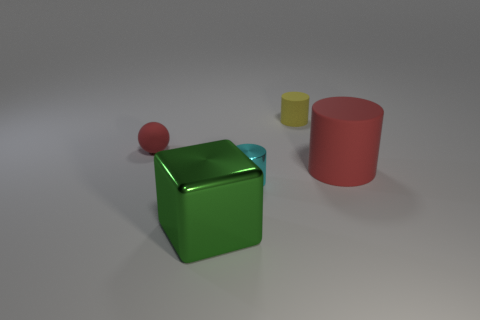Add 3 tiny cyan cylinders. How many objects exist? 8 Subtract all shiny cylinders. How many cylinders are left? 2 Subtract all cyan cylinders. How many cylinders are left? 2 Subtract all blocks. How many objects are left? 4 Add 3 metal cubes. How many metal cubes are left? 4 Add 1 red matte spheres. How many red matte spheres exist? 2 Subtract 0 gray blocks. How many objects are left? 5 Subtract all gray cylinders. Subtract all purple blocks. How many cylinders are left? 3 Subtract all big red cylinders. Subtract all large metallic blocks. How many objects are left? 3 